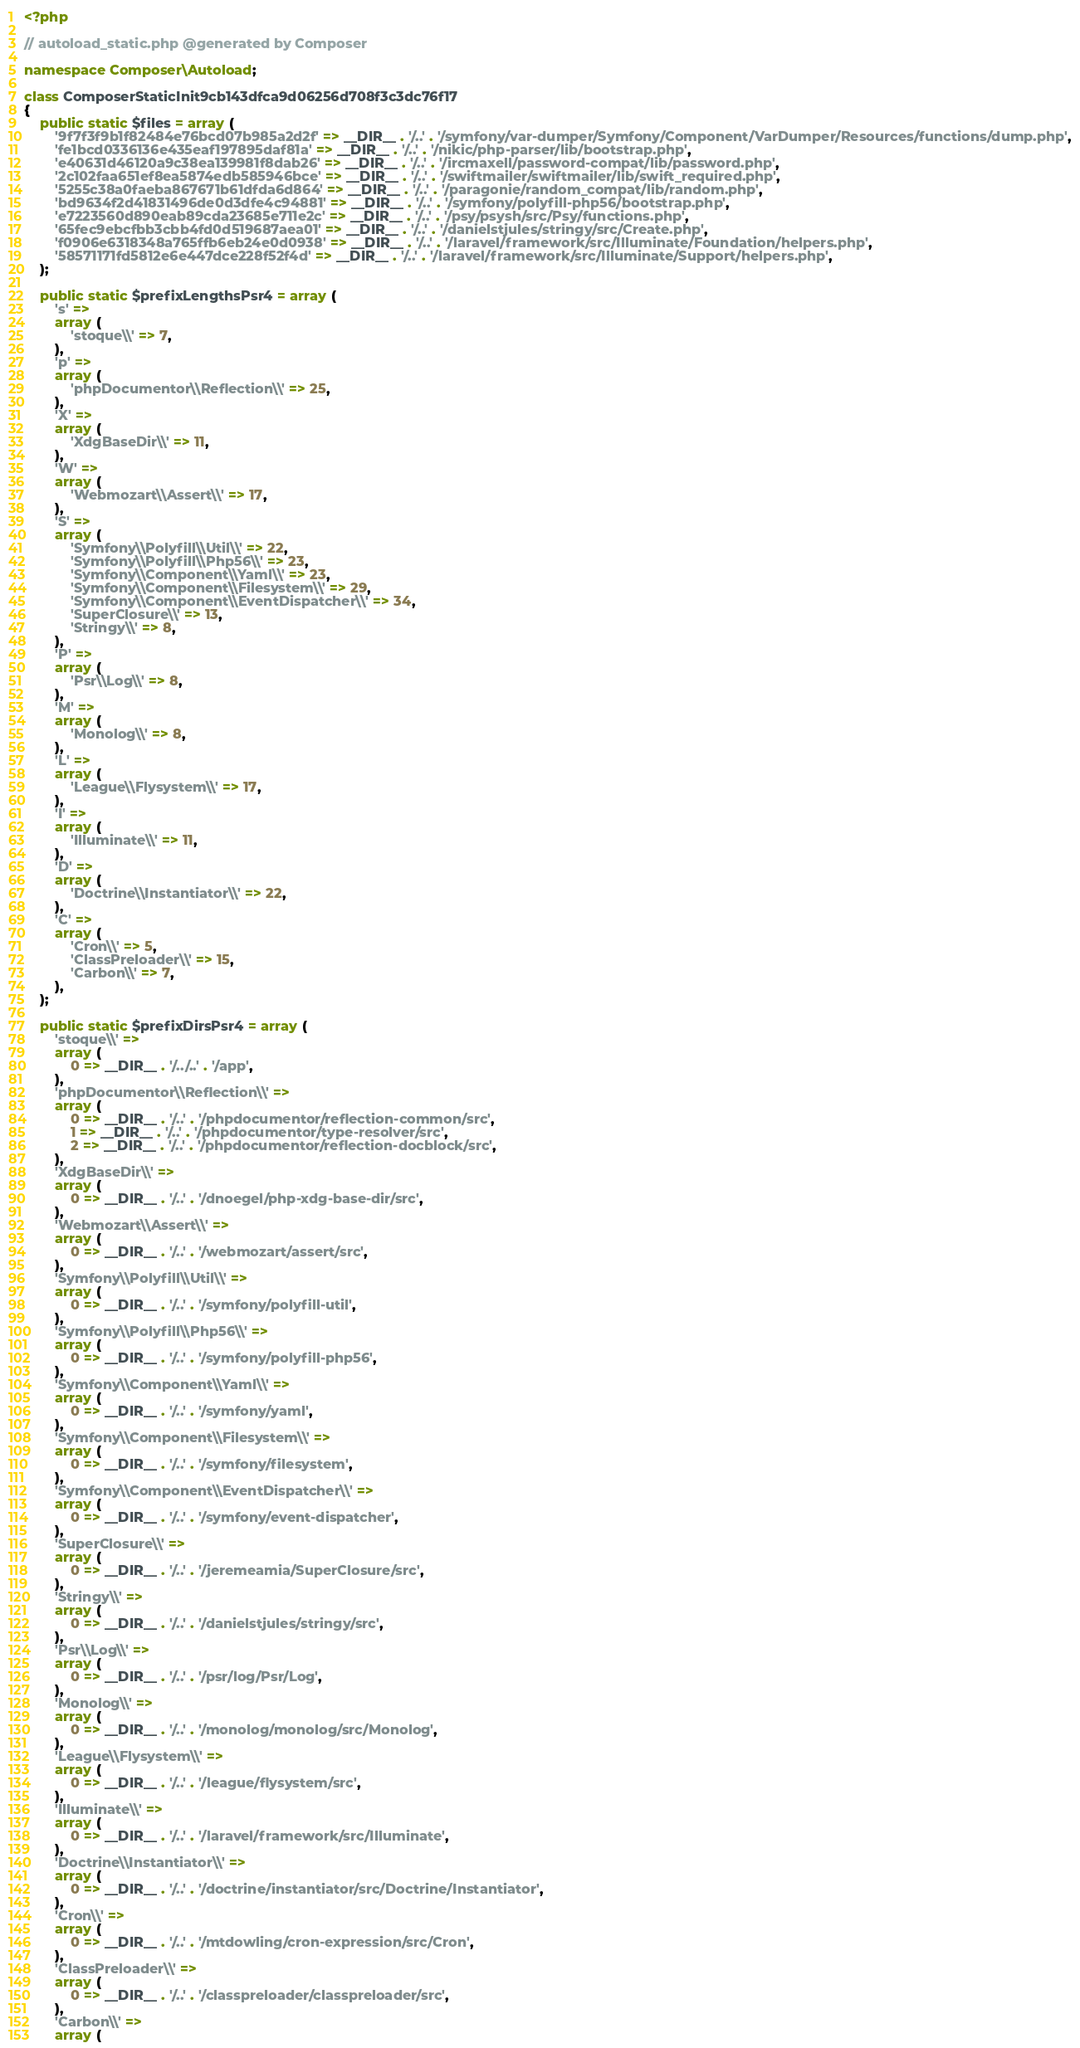<code> <loc_0><loc_0><loc_500><loc_500><_PHP_><?php

// autoload_static.php @generated by Composer

namespace Composer\Autoload;

class ComposerStaticInit9cb143dfca9d06256d708f3c3dc76f17
{
    public static $files = array (
        '9f7f3f9b1f82484e76bcd07b985a2d2f' => __DIR__ . '/..' . '/symfony/var-dumper/Symfony/Component/VarDumper/Resources/functions/dump.php',
        'fe1bcd0336136e435eaf197895daf81a' => __DIR__ . '/..' . '/nikic/php-parser/lib/bootstrap.php',
        'e40631d46120a9c38ea139981f8dab26' => __DIR__ . '/..' . '/ircmaxell/password-compat/lib/password.php',
        '2c102faa651ef8ea5874edb585946bce' => __DIR__ . '/..' . '/swiftmailer/swiftmailer/lib/swift_required.php',
        '5255c38a0faeba867671b61dfda6d864' => __DIR__ . '/..' . '/paragonie/random_compat/lib/random.php',
        'bd9634f2d41831496de0d3dfe4c94881' => __DIR__ . '/..' . '/symfony/polyfill-php56/bootstrap.php',
        'e7223560d890eab89cda23685e711e2c' => __DIR__ . '/..' . '/psy/psysh/src/Psy/functions.php',
        '65fec9ebcfbb3cbb4fd0d519687aea01' => __DIR__ . '/..' . '/danielstjules/stringy/src/Create.php',
        'f0906e6318348a765ffb6eb24e0d0938' => __DIR__ . '/..' . '/laravel/framework/src/Illuminate/Foundation/helpers.php',
        '58571171fd5812e6e447dce228f52f4d' => __DIR__ . '/..' . '/laravel/framework/src/Illuminate/Support/helpers.php',
    );

    public static $prefixLengthsPsr4 = array (
        's' => 
        array (
            'stoque\\' => 7,
        ),
        'p' => 
        array (
            'phpDocumentor\\Reflection\\' => 25,
        ),
        'X' => 
        array (
            'XdgBaseDir\\' => 11,
        ),
        'W' => 
        array (
            'Webmozart\\Assert\\' => 17,
        ),
        'S' => 
        array (
            'Symfony\\Polyfill\\Util\\' => 22,
            'Symfony\\Polyfill\\Php56\\' => 23,
            'Symfony\\Component\\Yaml\\' => 23,
            'Symfony\\Component\\Filesystem\\' => 29,
            'Symfony\\Component\\EventDispatcher\\' => 34,
            'SuperClosure\\' => 13,
            'Stringy\\' => 8,
        ),
        'P' => 
        array (
            'Psr\\Log\\' => 8,
        ),
        'M' => 
        array (
            'Monolog\\' => 8,
        ),
        'L' => 
        array (
            'League\\Flysystem\\' => 17,
        ),
        'I' => 
        array (
            'Illuminate\\' => 11,
        ),
        'D' => 
        array (
            'Doctrine\\Instantiator\\' => 22,
        ),
        'C' => 
        array (
            'Cron\\' => 5,
            'ClassPreloader\\' => 15,
            'Carbon\\' => 7,
        ),
    );

    public static $prefixDirsPsr4 = array (
        'stoque\\' => 
        array (
            0 => __DIR__ . '/../..' . '/app',
        ),
        'phpDocumentor\\Reflection\\' => 
        array (
            0 => __DIR__ . '/..' . '/phpdocumentor/reflection-common/src',
            1 => __DIR__ . '/..' . '/phpdocumentor/type-resolver/src',
            2 => __DIR__ . '/..' . '/phpdocumentor/reflection-docblock/src',
        ),
        'XdgBaseDir\\' => 
        array (
            0 => __DIR__ . '/..' . '/dnoegel/php-xdg-base-dir/src',
        ),
        'Webmozart\\Assert\\' => 
        array (
            0 => __DIR__ . '/..' . '/webmozart/assert/src',
        ),
        'Symfony\\Polyfill\\Util\\' => 
        array (
            0 => __DIR__ . '/..' . '/symfony/polyfill-util',
        ),
        'Symfony\\Polyfill\\Php56\\' => 
        array (
            0 => __DIR__ . '/..' . '/symfony/polyfill-php56',
        ),
        'Symfony\\Component\\Yaml\\' => 
        array (
            0 => __DIR__ . '/..' . '/symfony/yaml',
        ),
        'Symfony\\Component\\Filesystem\\' => 
        array (
            0 => __DIR__ . '/..' . '/symfony/filesystem',
        ),
        'Symfony\\Component\\EventDispatcher\\' => 
        array (
            0 => __DIR__ . '/..' . '/symfony/event-dispatcher',
        ),
        'SuperClosure\\' => 
        array (
            0 => __DIR__ . '/..' . '/jeremeamia/SuperClosure/src',
        ),
        'Stringy\\' => 
        array (
            0 => __DIR__ . '/..' . '/danielstjules/stringy/src',
        ),
        'Psr\\Log\\' => 
        array (
            0 => __DIR__ . '/..' . '/psr/log/Psr/Log',
        ),
        'Monolog\\' => 
        array (
            0 => __DIR__ . '/..' . '/monolog/monolog/src/Monolog',
        ),
        'League\\Flysystem\\' => 
        array (
            0 => __DIR__ . '/..' . '/league/flysystem/src',
        ),
        'Illuminate\\' => 
        array (
            0 => __DIR__ . '/..' . '/laravel/framework/src/Illuminate',
        ),
        'Doctrine\\Instantiator\\' => 
        array (
            0 => __DIR__ . '/..' . '/doctrine/instantiator/src/Doctrine/Instantiator',
        ),
        'Cron\\' => 
        array (
            0 => __DIR__ . '/..' . '/mtdowling/cron-expression/src/Cron',
        ),
        'ClassPreloader\\' => 
        array (
            0 => __DIR__ . '/..' . '/classpreloader/classpreloader/src',
        ),
        'Carbon\\' => 
        array (</code> 